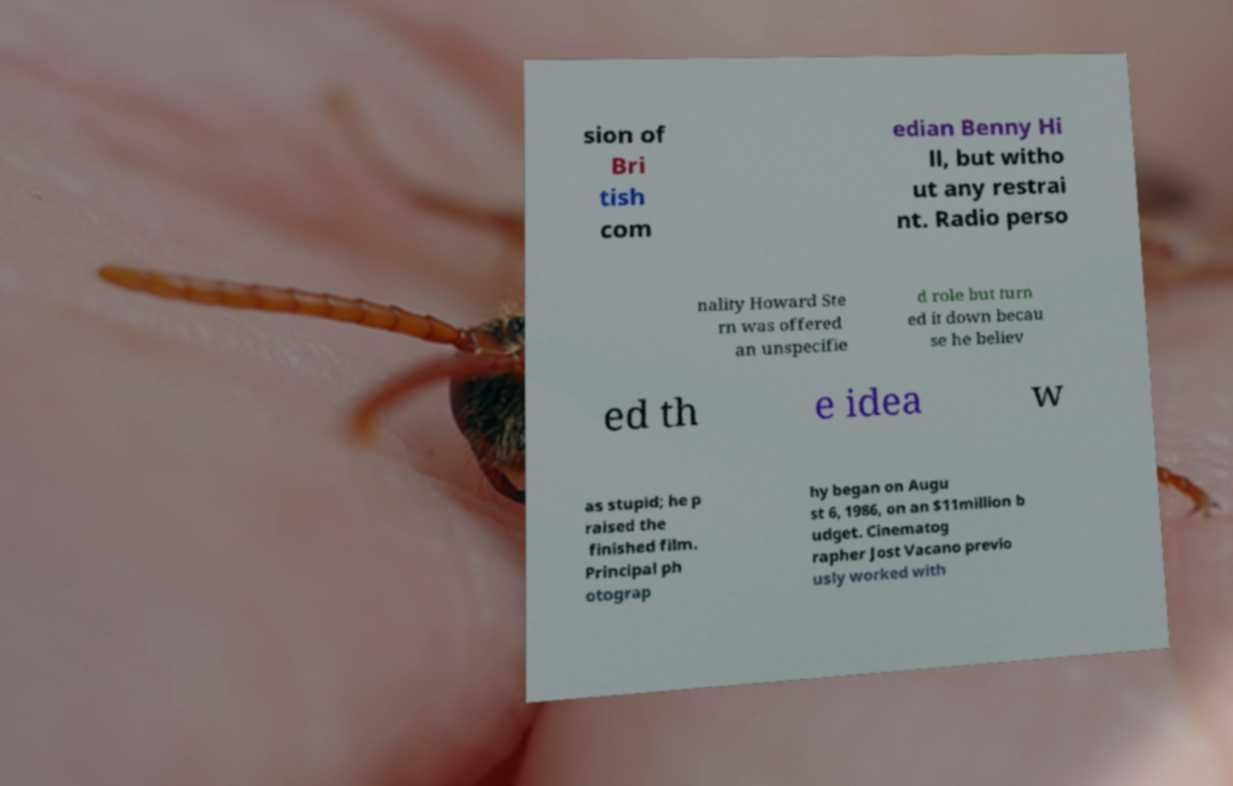For documentation purposes, I need the text within this image transcribed. Could you provide that? sion of Bri tish com edian Benny Hi ll, but witho ut any restrai nt. Radio perso nality Howard Ste rn was offered an unspecifie d role but turn ed it down becau se he believ ed th e idea w as stupid; he p raised the finished film. Principal ph otograp hy began on Augu st 6, 1986, on an $11million b udget. Cinematog rapher Jost Vacano previo usly worked with 